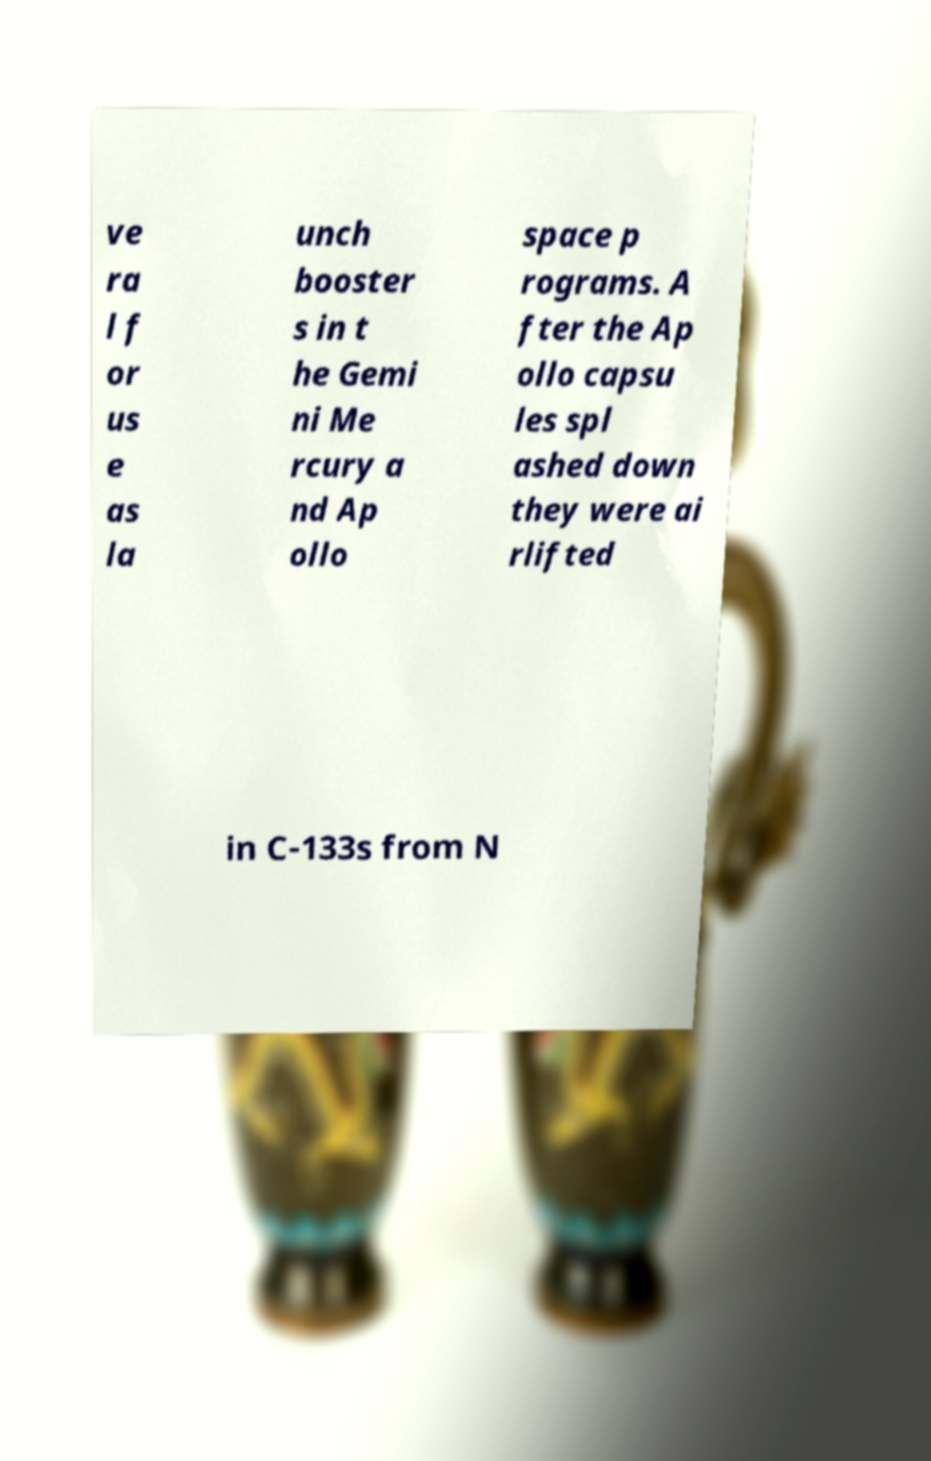There's text embedded in this image that I need extracted. Can you transcribe it verbatim? ve ra l f or us e as la unch booster s in t he Gemi ni Me rcury a nd Ap ollo space p rograms. A fter the Ap ollo capsu les spl ashed down they were ai rlifted in C-133s from N 